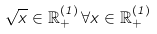<formula> <loc_0><loc_0><loc_500><loc_500>\sqrt { x } \in { \mathbb { R } } ^ { ( 1 ) } _ { + } \, \forall x \in { \mathbb { R } } ^ { ( 1 ) } _ { + }</formula> 